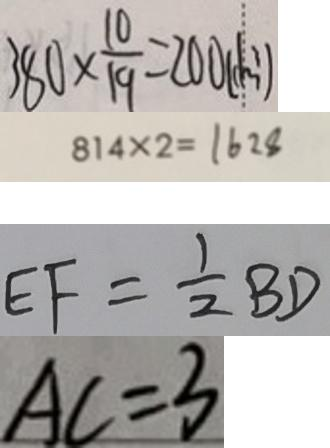Convert formula to latex. <formula><loc_0><loc_0><loc_500><loc_500>3 8 0 \times \frac { 1 0 } { 1 9 } = 2 0 0 ( d m ^ { 3 } ) 
 8 1 4 \times 2 = 1 6 2 8 
 E F = \frac { 1 } { 2 } B D 
 A C = 3</formula> 